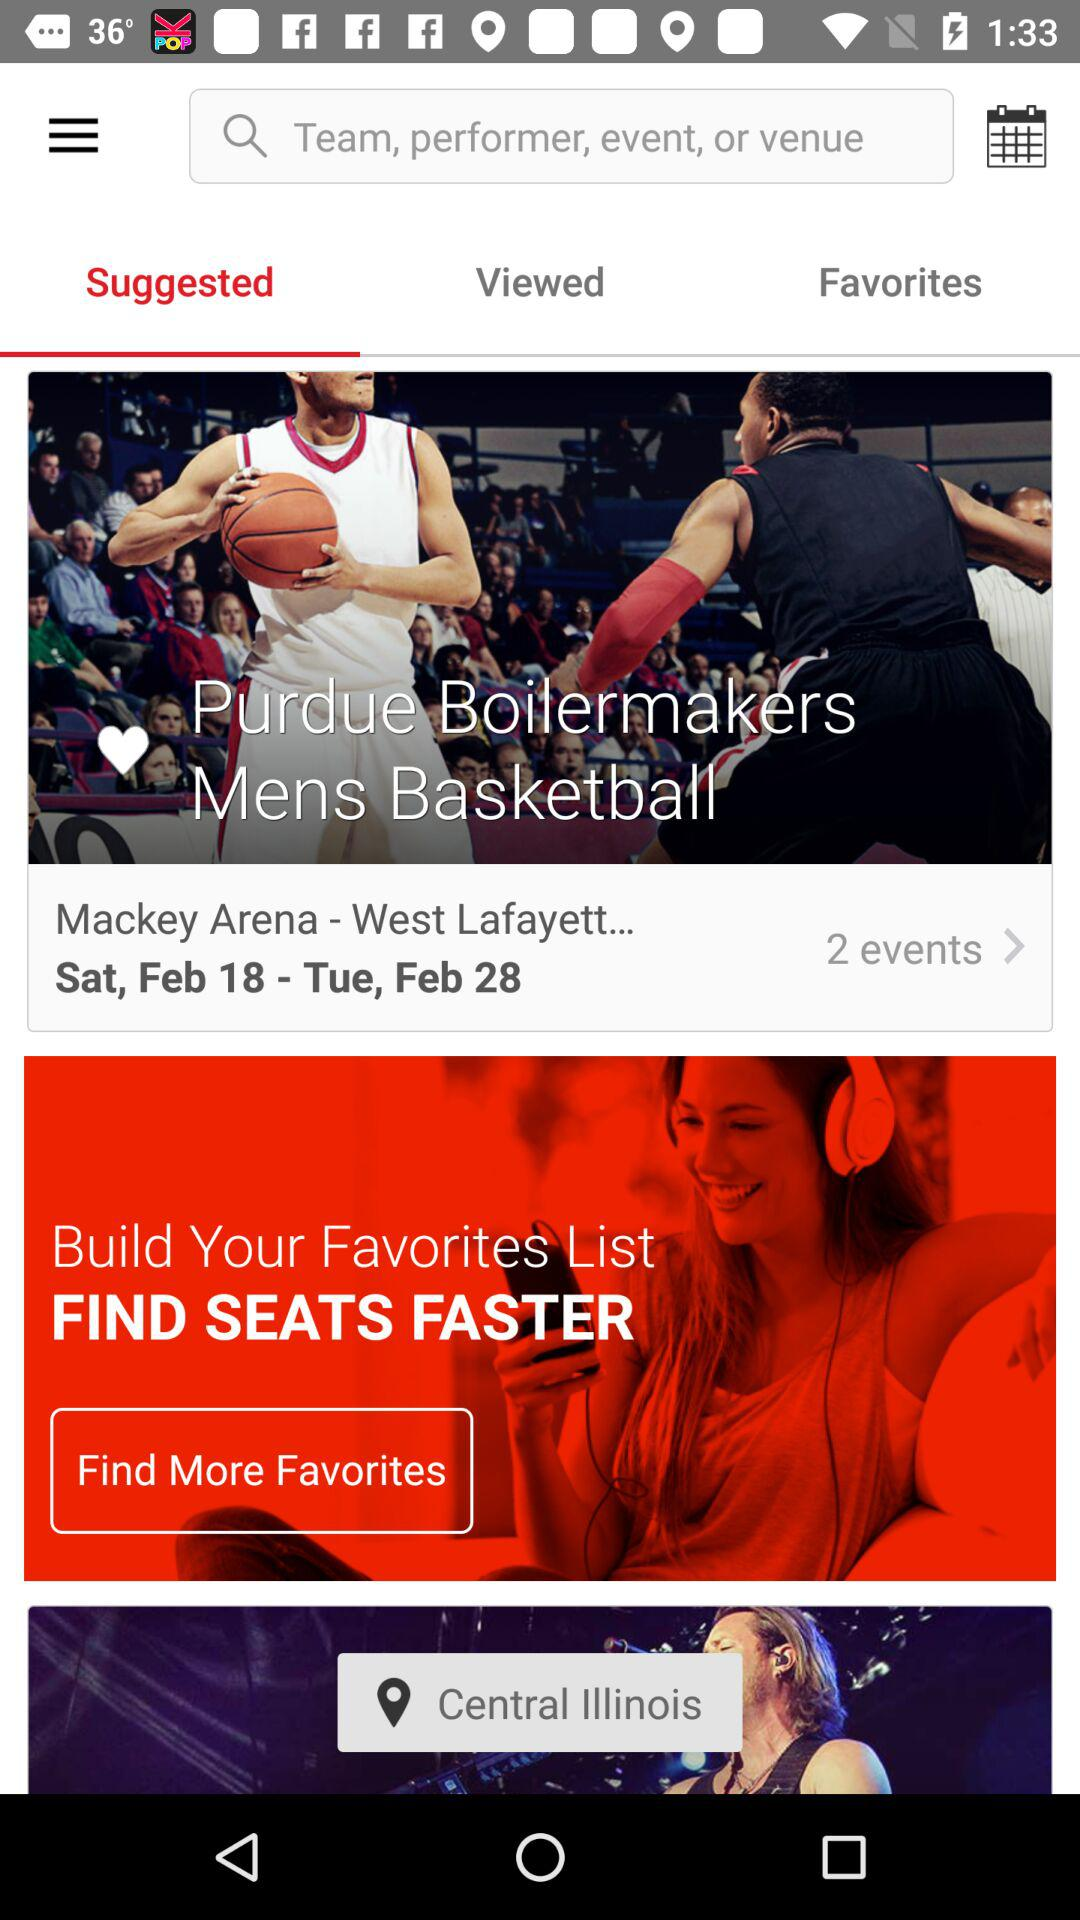On what date is the event scheduled? The events are scheduled from Saturday, February 18 to Tuesday, February 28. 